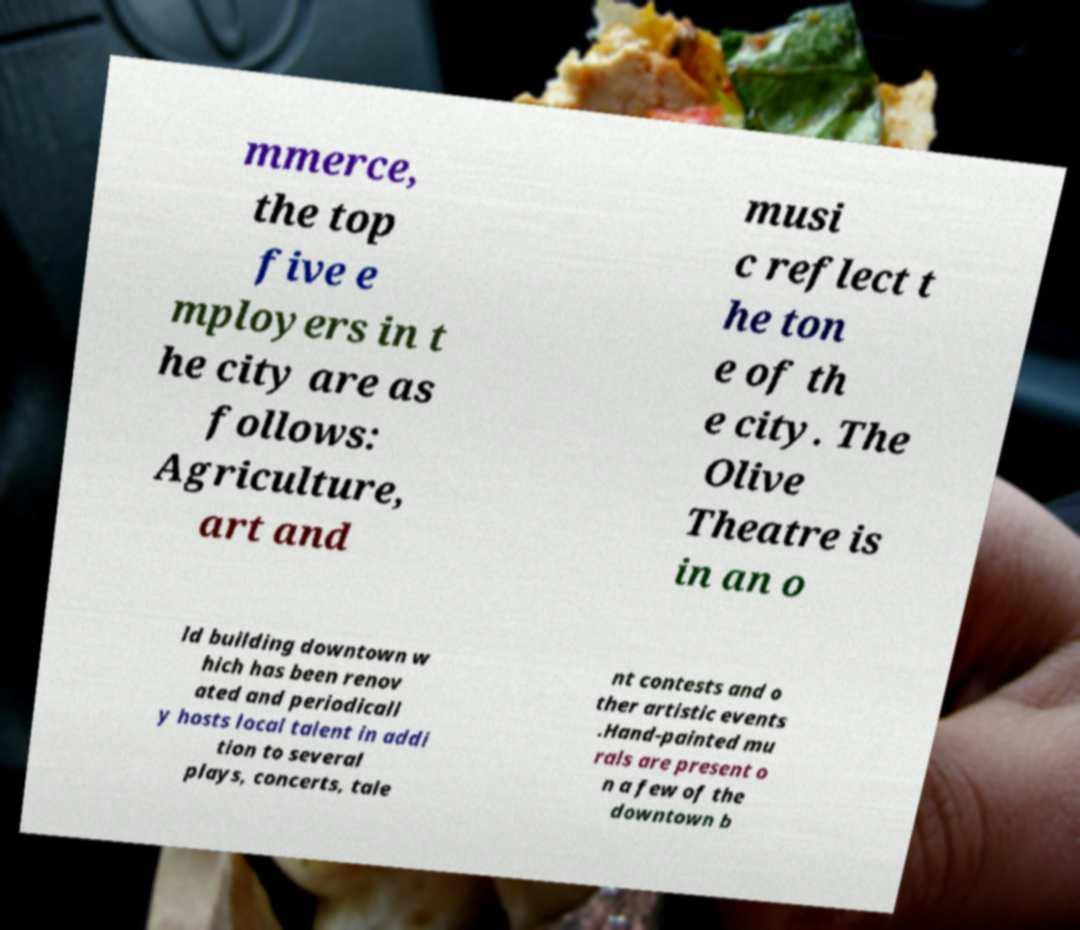I need the written content from this picture converted into text. Can you do that? mmerce, the top five e mployers in t he city are as follows: Agriculture, art and musi c reflect t he ton e of th e city. The Olive Theatre is in an o ld building downtown w hich has been renov ated and periodicall y hosts local talent in addi tion to several plays, concerts, tale nt contests and o ther artistic events .Hand-painted mu rals are present o n a few of the downtown b 